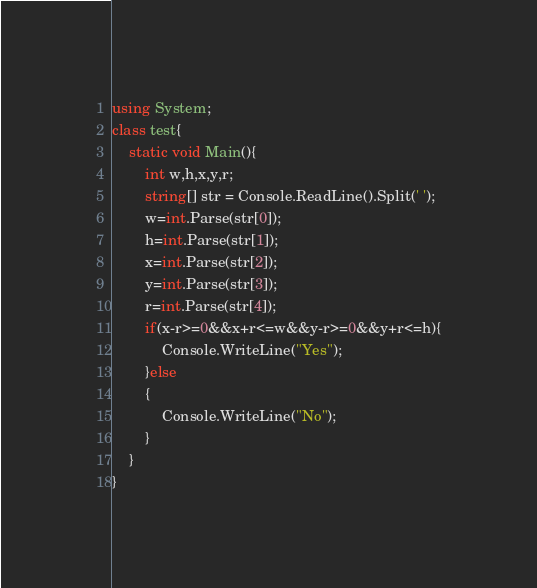Convert code to text. <code><loc_0><loc_0><loc_500><loc_500><_C#_>using System;
class test{
    static void Main(){
        int w,h,x,y,r;
        string[] str = Console.ReadLine().Split(' ');
        w=int.Parse(str[0]);
        h=int.Parse(str[1]);
        x=int.Parse(str[2]);
        y=int.Parse(str[3]);
        r=int.Parse(str[4]);
        if(x-r>=0&&x+r<=w&&y-r>=0&&y+r<=h){
            Console.WriteLine("Yes");
        }else
        {
            Console.WriteLine("No");
        }
    }
}
</code> 